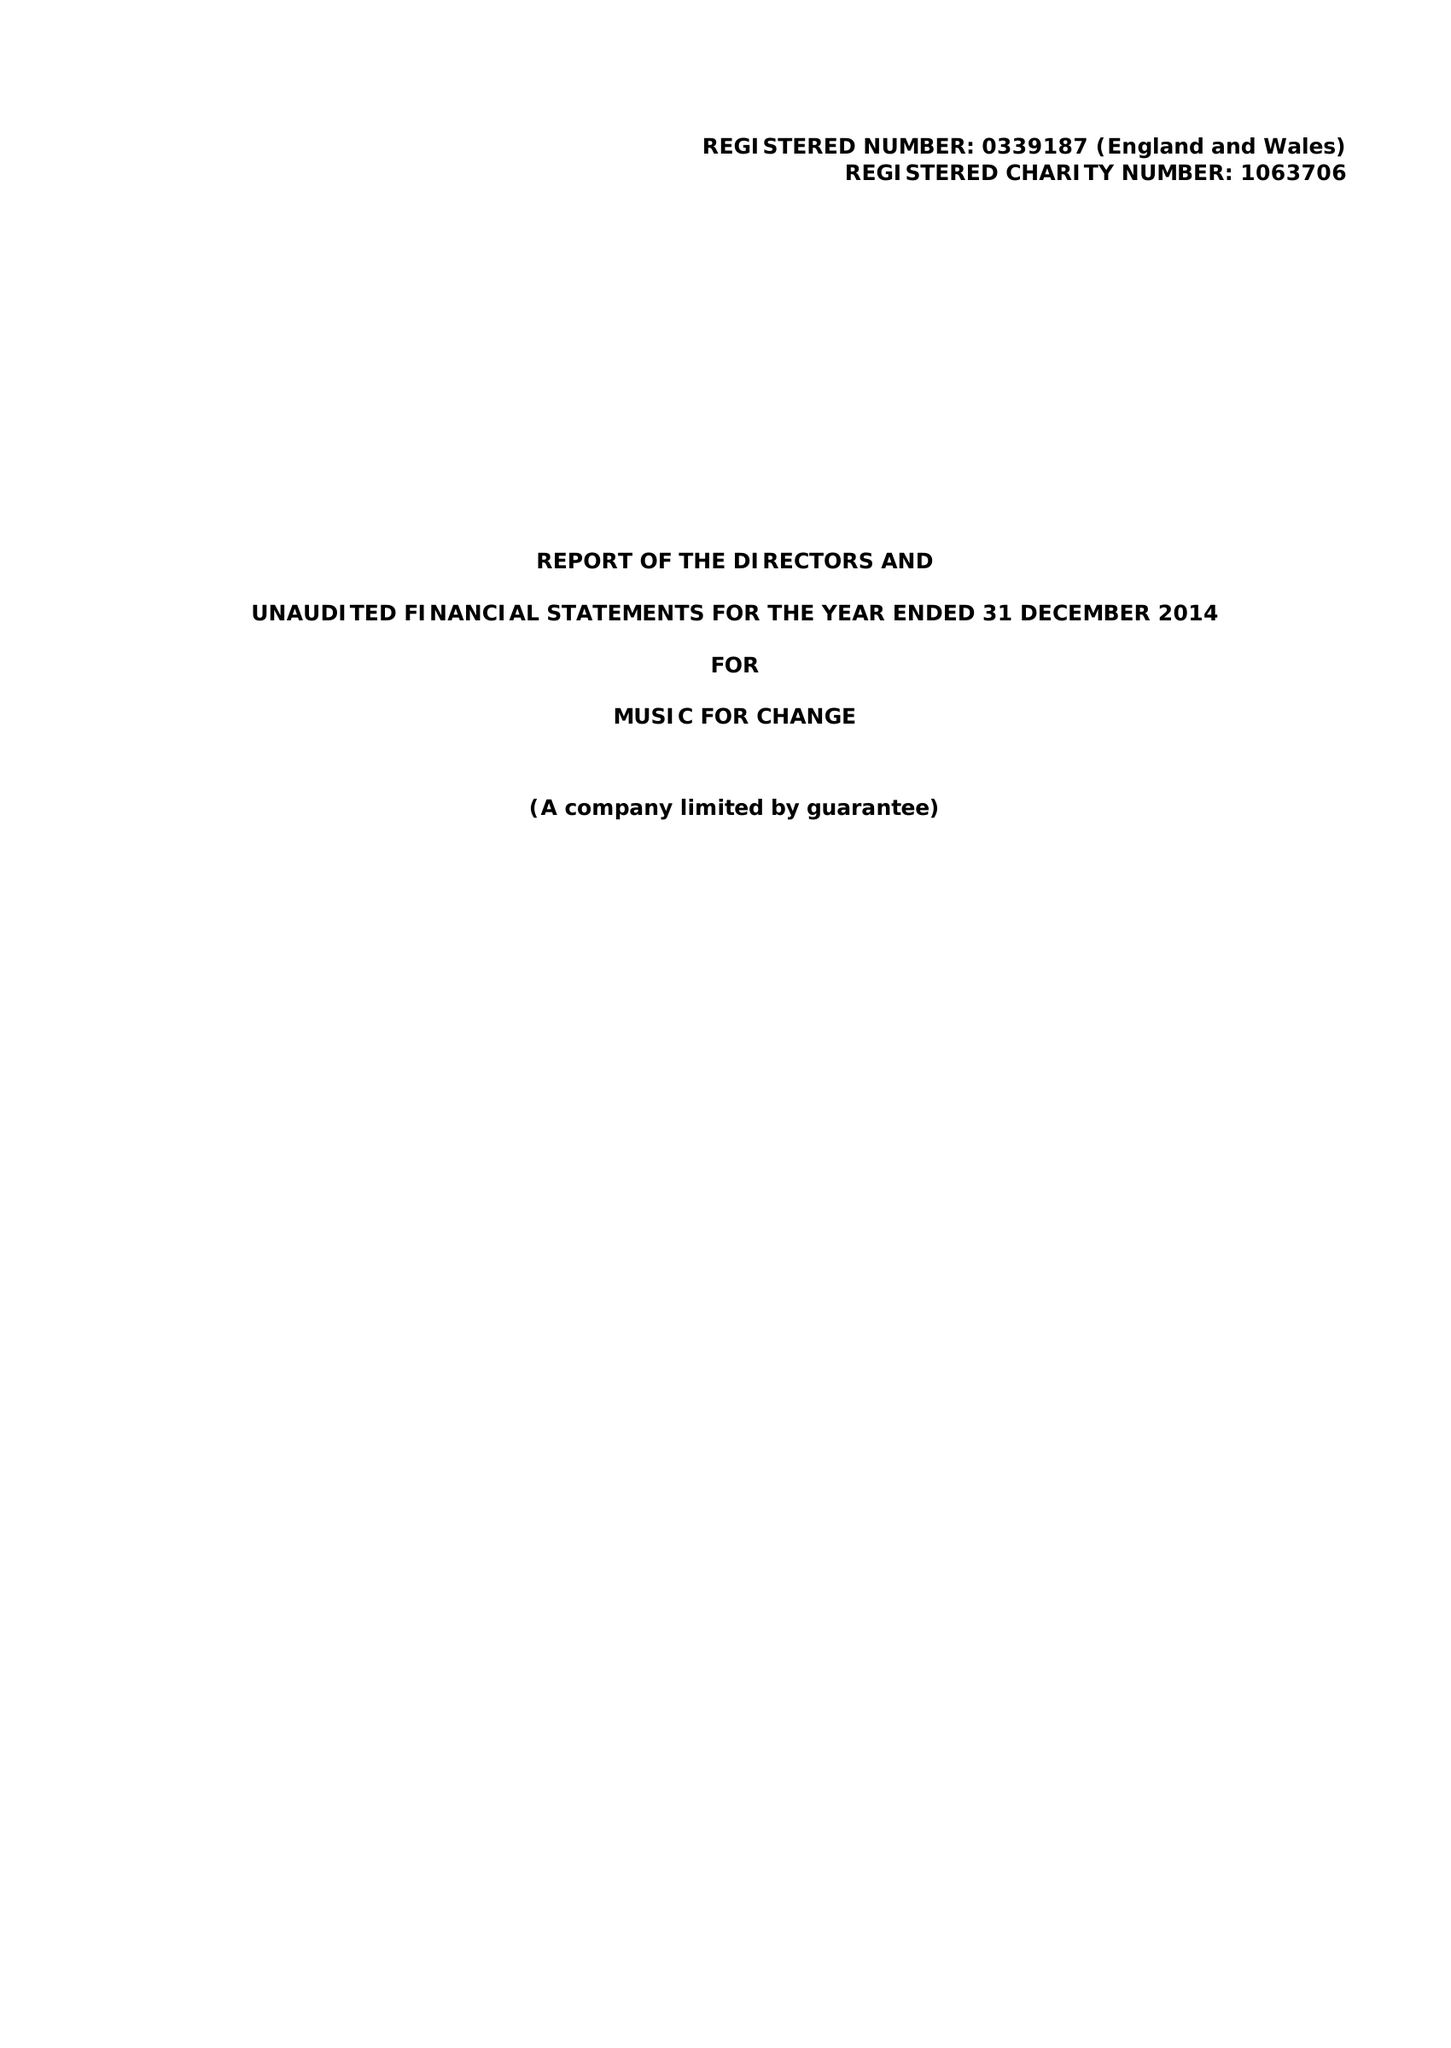What is the value for the address__postcode?
Answer the question using a single word or phrase. CT1 2NR 